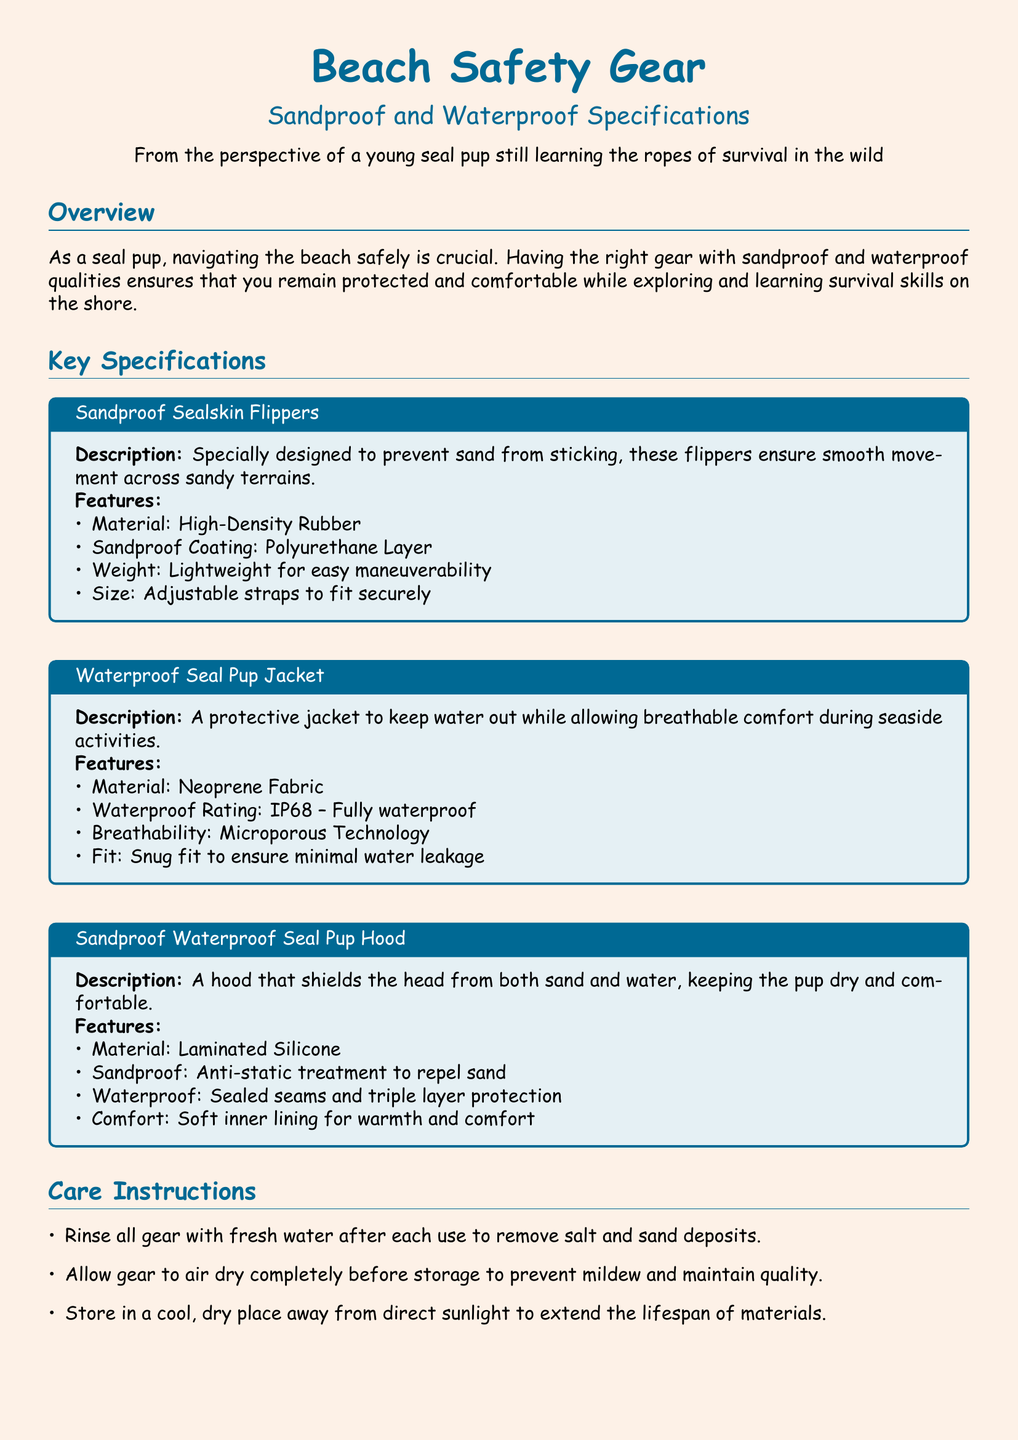What are the materials used for the Sandproof Seal Skin Flippers? The materials used are listed in the specifications section for the Sandproof Seal Skin Flippers, which states High-Density Rubber.
Answer: High-Density Rubber What is the waterproof rating of the Waterproof Seal Pup Jacket? The waterproof rating is mentioned in the specifications section of the Waterproof Seal Pup Jacket, listed as IP68.
Answer: IP68 What is the special feature of the Sandproof Waterproof Seal Pup Hood? The unique features of the Sandproof Waterproof Seal Pup Hood include anti-static treatment to repel sand and sealed seams for waterproofing.
Answer: Anti-static treatment What type of fabric is the Waterproof Seal Pup Jacket made from? The fabric type is specified in the techniques section for the Waterproof Seal Pup Jacket as Neoprene Fabric.
Answer: Neoprene Fabric What care instruction is provided for drying the gear? The care instructions specify allowing the gear to air dry completely before storage to maintain quality.
Answer: Air dry completely What does the note at the end of the document emphasize? The note emphasizes the importance of having the right gear for a young seal pup to safely enjoy and adapt to the beach environment.
Answer: Confidence How many features are listed for the Sandproof Seal Skin Flippers? The number of features is counted in the specifications section for the Sandproof Seal Skin Flippers, where four distinct features are listed.
Answer: Four What is the setback for using the gear in terms of convenience? The document mentions that the Sandproof Seal Skin Flippers are lightweight for easy maneuverability, relating to convenience.
Answer: Lightweight What should you do after each use of the gear? The care instruction states that you should rinse all gear with fresh water after each use to remove salt and sand deposits.
Answer: Rinse with fresh water 